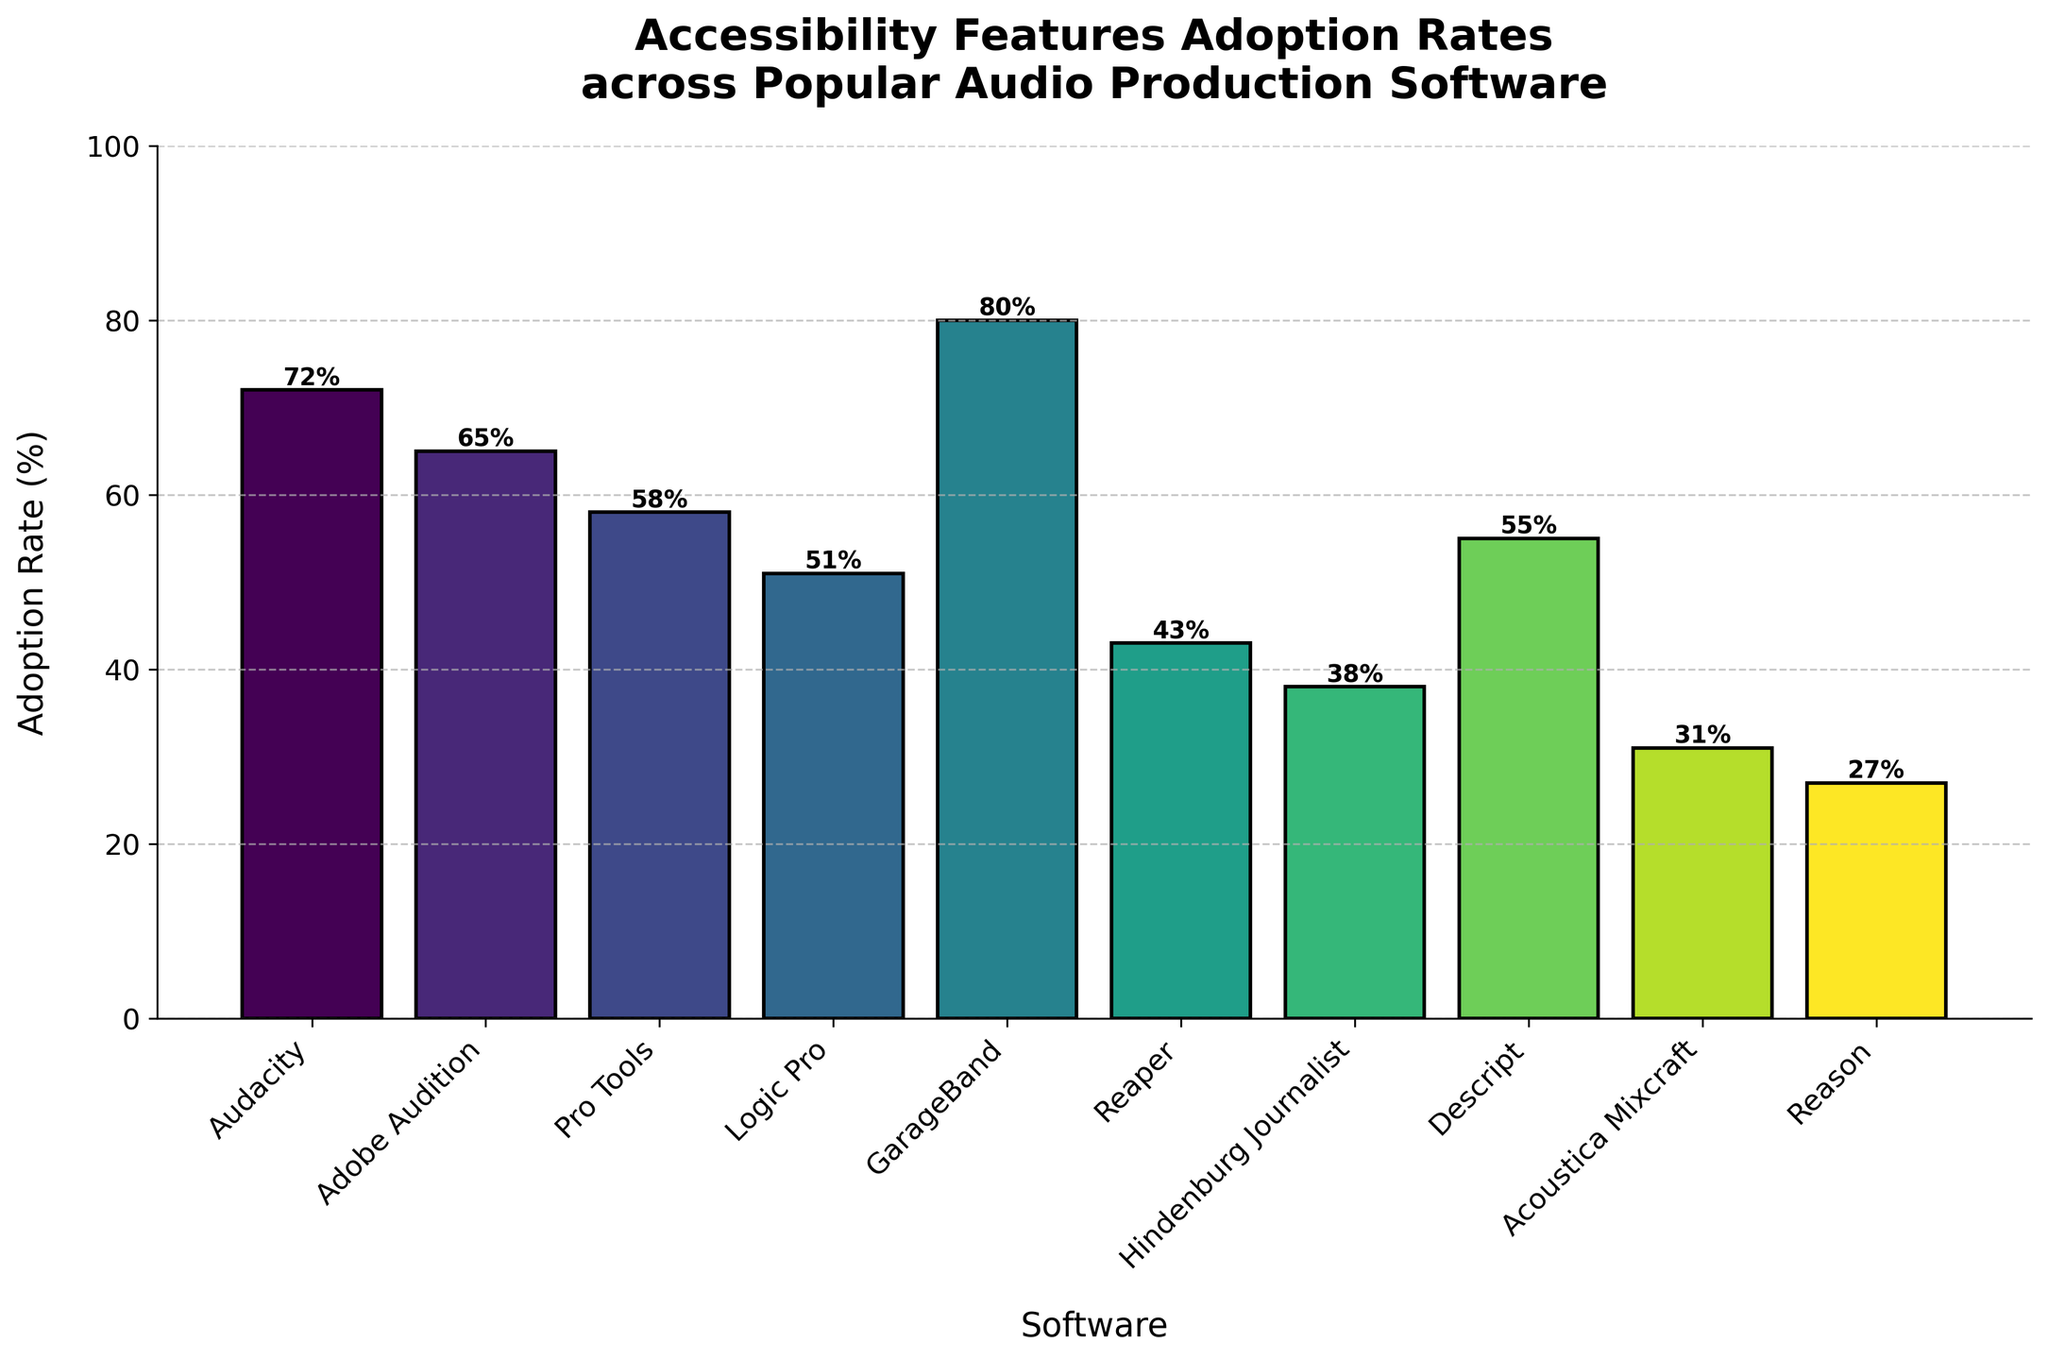Which software has the highest adoption rate? Identify the software with the greatest height in the bar chart. The color does not matter here.
Answer: GarageBand What is the difference in adoption rates between Audacity and Reaper? Find the adoption rates for Audacity and Reaper from the chart and subtract the smaller value from the larger value: 72% - 43% = 29%
Answer: 29% How many software have an adoption rate higher than 50%? Count the bars that have a height greater than 50. The software meeting this criterion are Audacity, Adobe Audition, GarageBand, Pro Tools, and Descript, resulting in five bars.
Answer: 5 What is the average adoption rate of Adobe Audition, Pro Tools, and Logic Pro? Sum up the adoption rates of these three software and divide by the number of software: (65% + 58% + 51%) / 3 = 58%
Answer: 58% Which software has the lowest adoption rate, and what is its value? Identify the shortest bar in the chart. The software associated with this bar will have the lowest adoption rate, which is Reason at 27%.
Answer: Reason, 27% Compare the adoption rates of Hindenburg Journalist and Descript. Which one is higher and by how much? Find the adoption rates of Hindenburg Journalist and Descript, then subtract the smaller from the larger: 55% - 38% = 17%. Descript has a higher adoption rate by 17%.
Answer: Descript by 17% Among the listed software, which ones have adoption rates between 30% and 60%? Identify the bars whose heights fall between 30 and 60. These include Pro Tools, Logic Pro, Reaper, Descript, and Acoustica Mixcraft.
Answer: Pro Tools, Logic Pro, Reaper, Descript, Acoustica Mixcraft What's the median adoption rate of the given software? List the adoption rates in ascending order: 27%, 31%, 38%, 43%, 51%, 55%, 58%, 65%, 72%, 80%. The middle values are 51% and 55%. The median is the average of these two: (51 + 55) / 2 = 53%.
Answer: 53% Which software has an adoption rate exactly 20% more than Hindenburg Journalist’s? Look for the software whose adoption rate is 38% + 20% = 58%. Pro Tools has an adoption rate of 58%.
Answer: Pro Tools Are there any software with adoption rates within 10% of Audacity's rate? Check for rates falling within the range of 62% to 82% (72% ± 10%). Adobe Audition with 65%, and GarageBand with 80% match this criterion.
Answer: Adobe Audition, GarageBand 